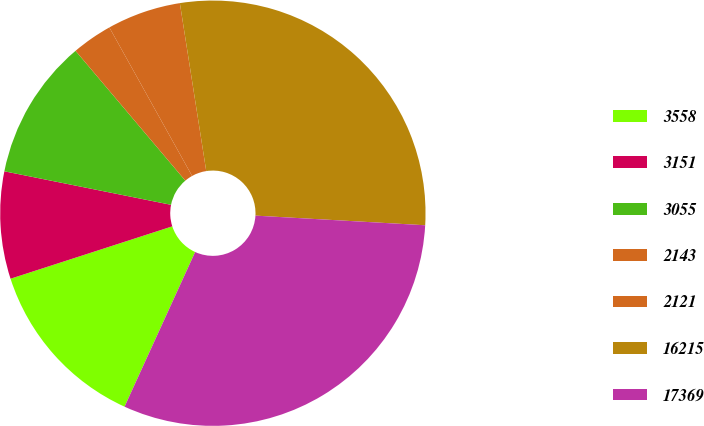Convert chart. <chart><loc_0><loc_0><loc_500><loc_500><pie_chart><fcel>3558<fcel>3151<fcel>3055<fcel>2143<fcel>2121<fcel>16215<fcel>17369<nl><fcel>13.2%<fcel>8.14%<fcel>10.67%<fcel>3.08%<fcel>5.61%<fcel>28.38%<fcel>30.91%<nl></chart> 